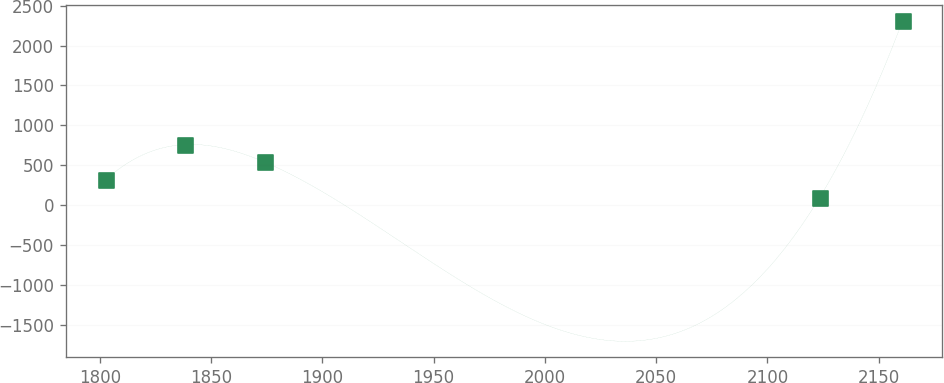Convert chart to OTSL. <chart><loc_0><loc_0><loc_500><loc_500><line_chart><ecel><fcel>Unnamed: 1<nl><fcel>1802.59<fcel>316.27<nl><fcel>1838.4<fcel>759.15<nl><fcel>1874.21<fcel>537.71<nl><fcel>2123.47<fcel>94.83<nl><fcel>2160.7<fcel>2309.26<nl></chart> 